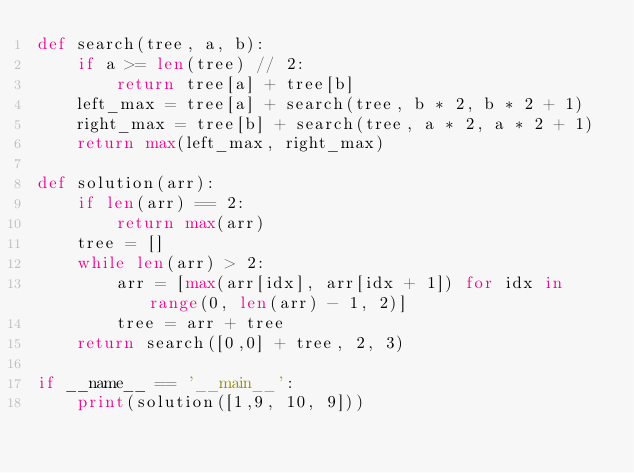Convert code to text. <code><loc_0><loc_0><loc_500><loc_500><_Python_>def search(tree, a, b):
    if a >= len(tree) // 2:
        return tree[a] + tree[b]
    left_max = tree[a] + search(tree, b * 2, b * 2 + 1)
    right_max = tree[b] + search(tree, a * 2, a * 2 + 1)
    return max(left_max, right_max)

def solution(arr):
    if len(arr) == 2:
        return max(arr)
    tree = []
    while len(arr) > 2:
        arr = [max(arr[idx], arr[idx + 1]) for idx in range(0, len(arr) - 1, 2)]
        tree = arr + tree
    return search([0,0] + tree, 2, 3)

if __name__ == '__main__':
    print(solution([1,9, 10, 9]))</code> 